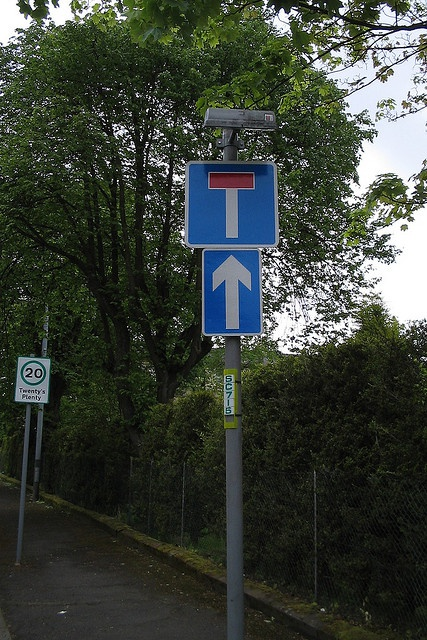Describe the objects in this image and their specific colors. I can see various objects in this image with different colors. 